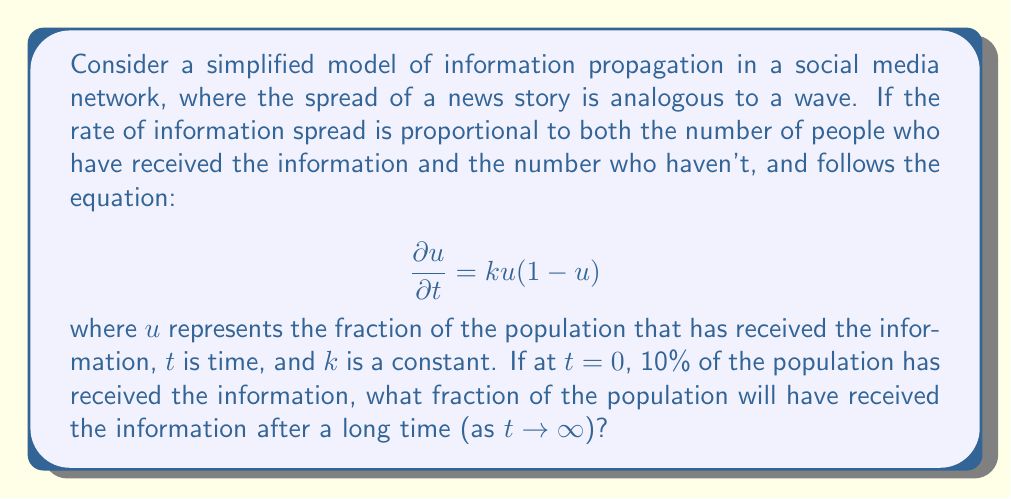Provide a solution to this math problem. To solve this problem, we'll follow these steps:

1) First, we recognize this equation as the logistic growth equation, which is often used to model the spread of information or adoption of new technologies.

2) The steady-state solution (as $t \to \infty$) can be found by setting $\frac{\partial u}{\partial t} = 0$:

   $$0 = k u(1-u)$$

3) This equation has two solutions:
   $u = 0$ or $u = 1$

4) The solution $u = 0$ represents the trivial case where no one ever receives the information. This is not relevant to our scenario.

5) The solution $u = 1$ represents the case where the entire population eventually receives the information.

6) Given that 10% of the population has already received the information at $t=0$, the information will continue to spread. Therefore, the relevant solution is $u = 1$.

7) This means that after a long time, 100% of the population will have received the information.

This model, while simplified, captures the essence of how information can spread rapidly through social networks, eventually reaching the entire connected population. It's particularly relevant to the study of media evolution, as it demonstrates how digital networks have accelerated the speed and reach of information dissemination compared to traditional press.
Answer: 1 (or 100%) 